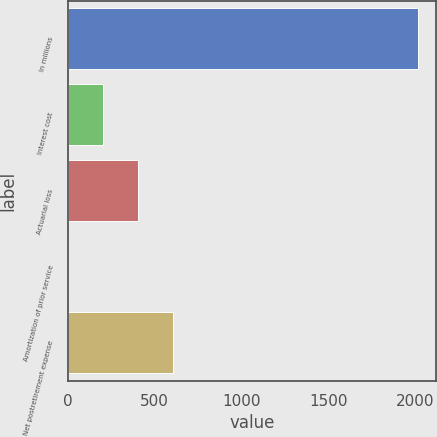Convert chart to OTSL. <chart><loc_0><loc_0><loc_500><loc_500><bar_chart><fcel>In millions<fcel>Interest cost<fcel>Actuarial loss<fcel>Amortization of prior service<fcel>Net postretirement expense<nl><fcel>2018<fcel>203.6<fcel>405.2<fcel>2<fcel>606.8<nl></chart> 